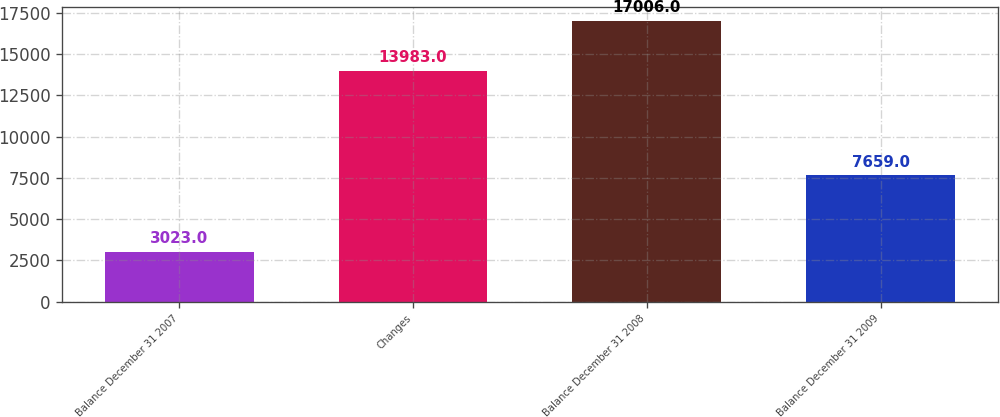Convert chart to OTSL. <chart><loc_0><loc_0><loc_500><loc_500><bar_chart><fcel>Balance December 31 2007<fcel>Changes<fcel>Balance December 31 2008<fcel>Balance December 31 2009<nl><fcel>3023<fcel>13983<fcel>17006<fcel>7659<nl></chart> 